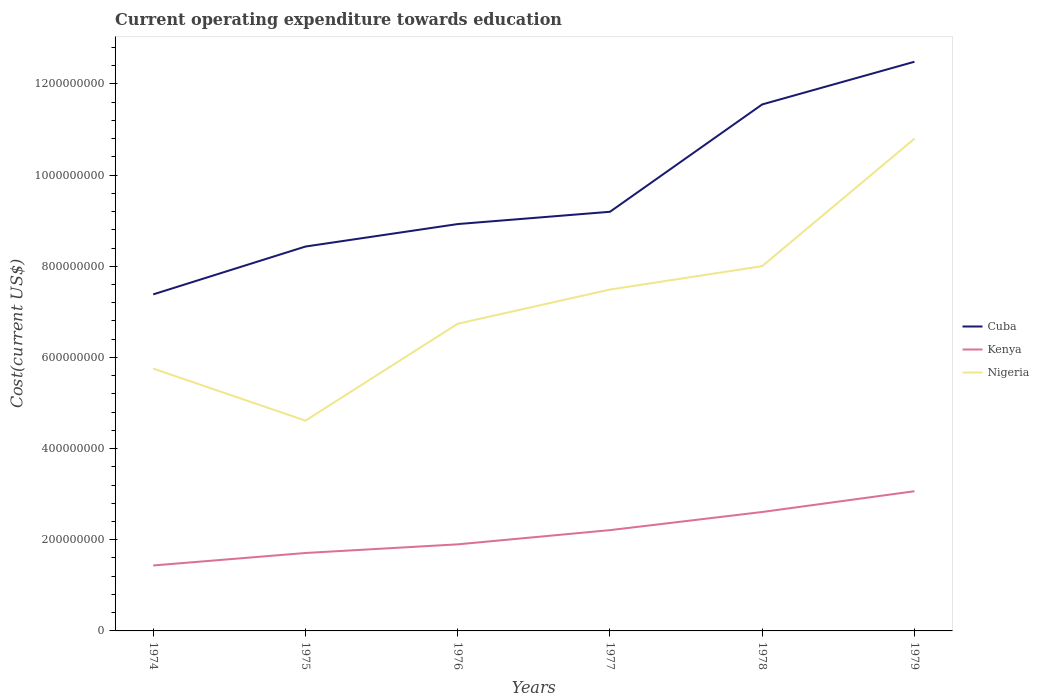How many different coloured lines are there?
Your answer should be compact. 3. Does the line corresponding to Nigeria intersect with the line corresponding to Cuba?
Provide a short and direct response. No. Is the number of lines equal to the number of legend labels?
Provide a short and direct response. Yes. Across all years, what is the maximum expenditure towards education in Cuba?
Keep it short and to the point. 7.38e+08. In which year was the expenditure towards education in Cuba maximum?
Your answer should be very brief. 1974. What is the total expenditure towards education in Kenya in the graph?
Your response must be concise. -4.63e+07. What is the difference between the highest and the second highest expenditure towards education in Cuba?
Provide a short and direct response. 5.10e+08. What is the difference between the highest and the lowest expenditure towards education in Nigeria?
Offer a terse response. 3. Is the expenditure towards education in Cuba strictly greater than the expenditure towards education in Kenya over the years?
Offer a very short reply. No. How many years are there in the graph?
Offer a very short reply. 6. What is the difference between two consecutive major ticks on the Y-axis?
Your answer should be very brief. 2.00e+08. Where does the legend appear in the graph?
Offer a terse response. Center right. What is the title of the graph?
Give a very brief answer. Current operating expenditure towards education. Does "Mexico" appear as one of the legend labels in the graph?
Offer a very short reply. No. What is the label or title of the Y-axis?
Make the answer very short. Cost(current US$). What is the Cost(current US$) in Cuba in 1974?
Keep it short and to the point. 7.38e+08. What is the Cost(current US$) of Kenya in 1974?
Give a very brief answer. 1.44e+08. What is the Cost(current US$) in Nigeria in 1974?
Keep it short and to the point. 5.76e+08. What is the Cost(current US$) in Cuba in 1975?
Ensure brevity in your answer.  8.43e+08. What is the Cost(current US$) of Kenya in 1975?
Your answer should be compact. 1.71e+08. What is the Cost(current US$) of Nigeria in 1975?
Provide a short and direct response. 4.61e+08. What is the Cost(current US$) of Cuba in 1976?
Ensure brevity in your answer.  8.93e+08. What is the Cost(current US$) of Kenya in 1976?
Keep it short and to the point. 1.90e+08. What is the Cost(current US$) of Nigeria in 1976?
Make the answer very short. 6.74e+08. What is the Cost(current US$) in Cuba in 1977?
Offer a very short reply. 9.20e+08. What is the Cost(current US$) in Kenya in 1977?
Your answer should be compact. 2.21e+08. What is the Cost(current US$) of Nigeria in 1977?
Ensure brevity in your answer.  7.49e+08. What is the Cost(current US$) in Cuba in 1978?
Your answer should be very brief. 1.16e+09. What is the Cost(current US$) of Kenya in 1978?
Your answer should be compact. 2.61e+08. What is the Cost(current US$) of Nigeria in 1978?
Make the answer very short. 8.00e+08. What is the Cost(current US$) of Cuba in 1979?
Give a very brief answer. 1.25e+09. What is the Cost(current US$) in Kenya in 1979?
Provide a short and direct response. 3.07e+08. What is the Cost(current US$) in Nigeria in 1979?
Ensure brevity in your answer.  1.08e+09. Across all years, what is the maximum Cost(current US$) of Cuba?
Make the answer very short. 1.25e+09. Across all years, what is the maximum Cost(current US$) in Kenya?
Your response must be concise. 3.07e+08. Across all years, what is the maximum Cost(current US$) of Nigeria?
Offer a very short reply. 1.08e+09. Across all years, what is the minimum Cost(current US$) in Cuba?
Offer a very short reply. 7.38e+08. Across all years, what is the minimum Cost(current US$) of Kenya?
Ensure brevity in your answer.  1.44e+08. Across all years, what is the minimum Cost(current US$) in Nigeria?
Give a very brief answer. 4.61e+08. What is the total Cost(current US$) of Cuba in the graph?
Offer a very short reply. 5.80e+09. What is the total Cost(current US$) of Kenya in the graph?
Make the answer very short. 1.29e+09. What is the total Cost(current US$) in Nigeria in the graph?
Keep it short and to the point. 4.34e+09. What is the difference between the Cost(current US$) in Cuba in 1974 and that in 1975?
Offer a very short reply. -1.05e+08. What is the difference between the Cost(current US$) of Kenya in 1974 and that in 1975?
Provide a succinct answer. -2.74e+07. What is the difference between the Cost(current US$) of Nigeria in 1974 and that in 1975?
Give a very brief answer. 1.14e+08. What is the difference between the Cost(current US$) of Cuba in 1974 and that in 1976?
Provide a short and direct response. -1.54e+08. What is the difference between the Cost(current US$) in Kenya in 1974 and that in 1976?
Make the answer very short. -4.63e+07. What is the difference between the Cost(current US$) of Nigeria in 1974 and that in 1976?
Your answer should be compact. -9.84e+07. What is the difference between the Cost(current US$) in Cuba in 1974 and that in 1977?
Give a very brief answer. -1.81e+08. What is the difference between the Cost(current US$) of Kenya in 1974 and that in 1977?
Keep it short and to the point. -7.75e+07. What is the difference between the Cost(current US$) of Nigeria in 1974 and that in 1977?
Ensure brevity in your answer.  -1.73e+08. What is the difference between the Cost(current US$) in Cuba in 1974 and that in 1978?
Provide a succinct answer. -4.17e+08. What is the difference between the Cost(current US$) in Kenya in 1974 and that in 1978?
Your response must be concise. -1.17e+08. What is the difference between the Cost(current US$) in Nigeria in 1974 and that in 1978?
Your response must be concise. -2.25e+08. What is the difference between the Cost(current US$) of Cuba in 1974 and that in 1979?
Your answer should be very brief. -5.10e+08. What is the difference between the Cost(current US$) in Kenya in 1974 and that in 1979?
Keep it short and to the point. -1.63e+08. What is the difference between the Cost(current US$) in Nigeria in 1974 and that in 1979?
Offer a very short reply. -5.04e+08. What is the difference between the Cost(current US$) of Cuba in 1975 and that in 1976?
Offer a very short reply. -4.93e+07. What is the difference between the Cost(current US$) in Kenya in 1975 and that in 1976?
Your answer should be very brief. -1.90e+07. What is the difference between the Cost(current US$) of Nigeria in 1975 and that in 1976?
Offer a very short reply. -2.13e+08. What is the difference between the Cost(current US$) of Cuba in 1975 and that in 1977?
Give a very brief answer. -7.63e+07. What is the difference between the Cost(current US$) in Kenya in 1975 and that in 1977?
Offer a very short reply. -5.02e+07. What is the difference between the Cost(current US$) of Nigeria in 1975 and that in 1977?
Give a very brief answer. -2.88e+08. What is the difference between the Cost(current US$) of Cuba in 1975 and that in 1978?
Offer a terse response. -3.12e+08. What is the difference between the Cost(current US$) in Kenya in 1975 and that in 1978?
Offer a very short reply. -8.99e+07. What is the difference between the Cost(current US$) in Nigeria in 1975 and that in 1978?
Provide a succinct answer. -3.39e+08. What is the difference between the Cost(current US$) in Cuba in 1975 and that in 1979?
Give a very brief answer. -4.05e+08. What is the difference between the Cost(current US$) of Kenya in 1975 and that in 1979?
Offer a very short reply. -1.36e+08. What is the difference between the Cost(current US$) of Nigeria in 1975 and that in 1979?
Make the answer very short. -6.19e+08. What is the difference between the Cost(current US$) of Cuba in 1976 and that in 1977?
Keep it short and to the point. -2.69e+07. What is the difference between the Cost(current US$) of Kenya in 1976 and that in 1977?
Provide a succinct answer. -3.12e+07. What is the difference between the Cost(current US$) of Nigeria in 1976 and that in 1977?
Make the answer very short. -7.50e+07. What is the difference between the Cost(current US$) in Cuba in 1976 and that in 1978?
Your answer should be very brief. -2.63e+08. What is the difference between the Cost(current US$) in Kenya in 1976 and that in 1978?
Provide a succinct answer. -7.10e+07. What is the difference between the Cost(current US$) in Nigeria in 1976 and that in 1978?
Ensure brevity in your answer.  -1.26e+08. What is the difference between the Cost(current US$) in Cuba in 1976 and that in 1979?
Keep it short and to the point. -3.56e+08. What is the difference between the Cost(current US$) in Kenya in 1976 and that in 1979?
Your response must be concise. -1.17e+08. What is the difference between the Cost(current US$) of Nigeria in 1976 and that in 1979?
Make the answer very short. -4.06e+08. What is the difference between the Cost(current US$) in Cuba in 1977 and that in 1978?
Your answer should be compact. -2.36e+08. What is the difference between the Cost(current US$) of Kenya in 1977 and that in 1978?
Provide a succinct answer. -3.98e+07. What is the difference between the Cost(current US$) of Nigeria in 1977 and that in 1978?
Your answer should be very brief. -5.14e+07. What is the difference between the Cost(current US$) in Cuba in 1977 and that in 1979?
Ensure brevity in your answer.  -3.29e+08. What is the difference between the Cost(current US$) in Kenya in 1977 and that in 1979?
Offer a very short reply. -8.54e+07. What is the difference between the Cost(current US$) of Nigeria in 1977 and that in 1979?
Your answer should be very brief. -3.31e+08. What is the difference between the Cost(current US$) in Cuba in 1978 and that in 1979?
Provide a short and direct response. -9.36e+07. What is the difference between the Cost(current US$) in Kenya in 1978 and that in 1979?
Your answer should be compact. -4.56e+07. What is the difference between the Cost(current US$) of Nigeria in 1978 and that in 1979?
Your answer should be compact. -2.80e+08. What is the difference between the Cost(current US$) of Cuba in 1974 and the Cost(current US$) of Kenya in 1975?
Make the answer very short. 5.67e+08. What is the difference between the Cost(current US$) of Cuba in 1974 and the Cost(current US$) of Nigeria in 1975?
Your answer should be compact. 2.77e+08. What is the difference between the Cost(current US$) of Kenya in 1974 and the Cost(current US$) of Nigeria in 1975?
Keep it short and to the point. -3.18e+08. What is the difference between the Cost(current US$) in Cuba in 1974 and the Cost(current US$) in Kenya in 1976?
Give a very brief answer. 5.48e+08. What is the difference between the Cost(current US$) in Cuba in 1974 and the Cost(current US$) in Nigeria in 1976?
Your answer should be very brief. 6.44e+07. What is the difference between the Cost(current US$) in Kenya in 1974 and the Cost(current US$) in Nigeria in 1976?
Your answer should be compact. -5.30e+08. What is the difference between the Cost(current US$) of Cuba in 1974 and the Cost(current US$) of Kenya in 1977?
Provide a succinct answer. 5.17e+08. What is the difference between the Cost(current US$) in Cuba in 1974 and the Cost(current US$) in Nigeria in 1977?
Your answer should be very brief. -1.06e+07. What is the difference between the Cost(current US$) in Kenya in 1974 and the Cost(current US$) in Nigeria in 1977?
Make the answer very short. -6.05e+08. What is the difference between the Cost(current US$) in Cuba in 1974 and the Cost(current US$) in Kenya in 1978?
Provide a succinct answer. 4.77e+08. What is the difference between the Cost(current US$) in Cuba in 1974 and the Cost(current US$) in Nigeria in 1978?
Your answer should be compact. -6.20e+07. What is the difference between the Cost(current US$) of Kenya in 1974 and the Cost(current US$) of Nigeria in 1978?
Ensure brevity in your answer.  -6.57e+08. What is the difference between the Cost(current US$) of Cuba in 1974 and the Cost(current US$) of Kenya in 1979?
Offer a very short reply. 4.32e+08. What is the difference between the Cost(current US$) of Cuba in 1974 and the Cost(current US$) of Nigeria in 1979?
Give a very brief answer. -3.42e+08. What is the difference between the Cost(current US$) in Kenya in 1974 and the Cost(current US$) in Nigeria in 1979?
Your response must be concise. -9.36e+08. What is the difference between the Cost(current US$) in Cuba in 1975 and the Cost(current US$) in Kenya in 1976?
Your answer should be compact. 6.53e+08. What is the difference between the Cost(current US$) of Cuba in 1975 and the Cost(current US$) of Nigeria in 1976?
Provide a succinct answer. 1.69e+08. What is the difference between the Cost(current US$) of Kenya in 1975 and the Cost(current US$) of Nigeria in 1976?
Ensure brevity in your answer.  -5.03e+08. What is the difference between the Cost(current US$) of Cuba in 1975 and the Cost(current US$) of Kenya in 1977?
Provide a short and direct response. 6.22e+08. What is the difference between the Cost(current US$) of Cuba in 1975 and the Cost(current US$) of Nigeria in 1977?
Give a very brief answer. 9.44e+07. What is the difference between the Cost(current US$) in Kenya in 1975 and the Cost(current US$) in Nigeria in 1977?
Keep it short and to the point. -5.78e+08. What is the difference between the Cost(current US$) in Cuba in 1975 and the Cost(current US$) in Kenya in 1978?
Provide a succinct answer. 5.82e+08. What is the difference between the Cost(current US$) of Cuba in 1975 and the Cost(current US$) of Nigeria in 1978?
Offer a terse response. 4.30e+07. What is the difference between the Cost(current US$) in Kenya in 1975 and the Cost(current US$) in Nigeria in 1978?
Your response must be concise. -6.29e+08. What is the difference between the Cost(current US$) in Cuba in 1975 and the Cost(current US$) in Kenya in 1979?
Your response must be concise. 5.37e+08. What is the difference between the Cost(current US$) in Cuba in 1975 and the Cost(current US$) in Nigeria in 1979?
Make the answer very short. -2.37e+08. What is the difference between the Cost(current US$) in Kenya in 1975 and the Cost(current US$) in Nigeria in 1979?
Provide a short and direct response. -9.09e+08. What is the difference between the Cost(current US$) of Cuba in 1976 and the Cost(current US$) of Kenya in 1977?
Offer a terse response. 6.72e+08. What is the difference between the Cost(current US$) of Cuba in 1976 and the Cost(current US$) of Nigeria in 1977?
Provide a succinct answer. 1.44e+08. What is the difference between the Cost(current US$) of Kenya in 1976 and the Cost(current US$) of Nigeria in 1977?
Give a very brief answer. -5.59e+08. What is the difference between the Cost(current US$) of Cuba in 1976 and the Cost(current US$) of Kenya in 1978?
Provide a succinct answer. 6.32e+08. What is the difference between the Cost(current US$) of Cuba in 1976 and the Cost(current US$) of Nigeria in 1978?
Give a very brief answer. 9.23e+07. What is the difference between the Cost(current US$) in Kenya in 1976 and the Cost(current US$) in Nigeria in 1978?
Offer a very short reply. -6.10e+08. What is the difference between the Cost(current US$) in Cuba in 1976 and the Cost(current US$) in Kenya in 1979?
Keep it short and to the point. 5.86e+08. What is the difference between the Cost(current US$) of Cuba in 1976 and the Cost(current US$) of Nigeria in 1979?
Offer a very short reply. -1.87e+08. What is the difference between the Cost(current US$) of Kenya in 1976 and the Cost(current US$) of Nigeria in 1979?
Your answer should be very brief. -8.90e+08. What is the difference between the Cost(current US$) of Cuba in 1977 and the Cost(current US$) of Kenya in 1978?
Make the answer very short. 6.59e+08. What is the difference between the Cost(current US$) in Cuba in 1977 and the Cost(current US$) in Nigeria in 1978?
Your answer should be very brief. 1.19e+08. What is the difference between the Cost(current US$) of Kenya in 1977 and the Cost(current US$) of Nigeria in 1978?
Your answer should be very brief. -5.79e+08. What is the difference between the Cost(current US$) of Cuba in 1977 and the Cost(current US$) of Kenya in 1979?
Keep it short and to the point. 6.13e+08. What is the difference between the Cost(current US$) in Cuba in 1977 and the Cost(current US$) in Nigeria in 1979?
Offer a terse response. -1.60e+08. What is the difference between the Cost(current US$) in Kenya in 1977 and the Cost(current US$) in Nigeria in 1979?
Offer a terse response. -8.59e+08. What is the difference between the Cost(current US$) in Cuba in 1978 and the Cost(current US$) in Kenya in 1979?
Offer a terse response. 8.49e+08. What is the difference between the Cost(current US$) of Cuba in 1978 and the Cost(current US$) of Nigeria in 1979?
Offer a terse response. 7.51e+07. What is the difference between the Cost(current US$) in Kenya in 1978 and the Cost(current US$) in Nigeria in 1979?
Keep it short and to the point. -8.19e+08. What is the average Cost(current US$) of Cuba per year?
Give a very brief answer. 9.66e+08. What is the average Cost(current US$) of Kenya per year?
Keep it short and to the point. 2.16e+08. What is the average Cost(current US$) of Nigeria per year?
Provide a short and direct response. 7.23e+08. In the year 1974, what is the difference between the Cost(current US$) of Cuba and Cost(current US$) of Kenya?
Give a very brief answer. 5.95e+08. In the year 1974, what is the difference between the Cost(current US$) in Cuba and Cost(current US$) in Nigeria?
Give a very brief answer. 1.63e+08. In the year 1974, what is the difference between the Cost(current US$) of Kenya and Cost(current US$) of Nigeria?
Offer a terse response. -4.32e+08. In the year 1975, what is the difference between the Cost(current US$) in Cuba and Cost(current US$) in Kenya?
Your answer should be compact. 6.72e+08. In the year 1975, what is the difference between the Cost(current US$) of Cuba and Cost(current US$) of Nigeria?
Your answer should be very brief. 3.82e+08. In the year 1975, what is the difference between the Cost(current US$) of Kenya and Cost(current US$) of Nigeria?
Give a very brief answer. -2.90e+08. In the year 1976, what is the difference between the Cost(current US$) in Cuba and Cost(current US$) in Kenya?
Provide a succinct answer. 7.03e+08. In the year 1976, what is the difference between the Cost(current US$) in Cuba and Cost(current US$) in Nigeria?
Offer a very short reply. 2.19e+08. In the year 1976, what is the difference between the Cost(current US$) of Kenya and Cost(current US$) of Nigeria?
Offer a very short reply. -4.84e+08. In the year 1977, what is the difference between the Cost(current US$) in Cuba and Cost(current US$) in Kenya?
Your response must be concise. 6.98e+08. In the year 1977, what is the difference between the Cost(current US$) of Cuba and Cost(current US$) of Nigeria?
Your response must be concise. 1.71e+08. In the year 1977, what is the difference between the Cost(current US$) of Kenya and Cost(current US$) of Nigeria?
Provide a short and direct response. -5.28e+08. In the year 1978, what is the difference between the Cost(current US$) of Cuba and Cost(current US$) of Kenya?
Your answer should be compact. 8.94e+08. In the year 1978, what is the difference between the Cost(current US$) of Cuba and Cost(current US$) of Nigeria?
Provide a short and direct response. 3.55e+08. In the year 1978, what is the difference between the Cost(current US$) of Kenya and Cost(current US$) of Nigeria?
Offer a terse response. -5.39e+08. In the year 1979, what is the difference between the Cost(current US$) of Cuba and Cost(current US$) of Kenya?
Provide a succinct answer. 9.42e+08. In the year 1979, what is the difference between the Cost(current US$) of Cuba and Cost(current US$) of Nigeria?
Keep it short and to the point. 1.69e+08. In the year 1979, what is the difference between the Cost(current US$) of Kenya and Cost(current US$) of Nigeria?
Provide a short and direct response. -7.74e+08. What is the ratio of the Cost(current US$) of Cuba in 1974 to that in 1975?
Your answer should be very brief. 0.88. What is the ratio of the Cost(current US$) of Kenya in 1974 to that in 1975?
Provide a short and direct response. 0.84. What is the ratio of the Cost(current US$) of Nigeria in 1974 to that in 1975?
Your answer should be compact. 1.25. What is the ratio of the Cost(current US$) of Cuba in 1974 to that in 1976?
Your answer should be compact. 0.83. What is the ratio of the Cost(current US$) of Kenya in 1974 to that in 1976?
Give a very brief answer. 0.76. What is the ratio of the Cost(current US$) in Nigeria in 1974 to that in 1976?
Offer a terse response. 0.85. What is the ratio of the Cost(current US$) in Cuba in 1974 to that in 1977?
Offer a terse response. 0.8. What is the ratio of the Cost(current US$) of Kenya in 1974 to that in 1977?
Give a very brief answer. 0.65. What is the ratio of the Cost(current US$) in Nigeria in 1974 to that in 1977?
Your answer should be very brief. 0.77. What is the ratio of the Cost(current US$) in Cuba in 1974 to that in 1978?
Give a very brief answer. 0.64. What is the ratio of the Cost(current US$) in Kenya in 1974 to that in 1978?
Provide a succinct answer. 0.55. What is the ratio of the Cost(current US$) of Nigeria in 1974 to that in 1978?
Your response must be concise. 0.72. What is the ratio of the Cost(current US$) in Cuba in 1974 to that in 1979?
Provide a short and direct response. 0.59. What is the ratio of the Cost(current US$) in Kenya in 1974 to that in 1979?
Make the answer very short. 0.47. What is the ratio of the Cost(current US$) of Nigeria in 1974 to that in 1979?
Give a very brief answer. 0.53. What is the ratio of the Cost(current US$) in Cuba in 1975 to that in 1976?
Offer a very short reply. 0.94. What is the ratio of the Cost(current US$) in Kenya in 1975 to that in 1976?
Provide a succinct answer. 0.9. What is the ratio of the Cost(current US$) in Nigeria in 1975 to that in 1976?
Your answer should be very brief. 0.68. What is the ratio of the Cost(current US$) of Cuba in 1975 to that in 1977?
Give a very brief answer. 0.92. What is the ratio of the Cost(current US$) of Kenya in 1975 to that in 1977?
Make the answer very short. 0.77. What is the ratio of the Cost(current US$) of Nigeria in 1975 to that in 1977?
Your answer should be compact. 0.62. What is the ratio of the Cost(current US$) in Cuba in 1975 to that in 1978?
Ensure brevity in your answer.  0.73. What is the ratio of the Cost(current US$) of Kenya in 1975 to that in 1978?
Provide a short and direct response. 0.66. What is the ratio of the Cost(current US$) in Nigeria in 1975 to that in 1978?
Keep it short and to the point. 0.58. What is the ratio of the Cost(current US$) of Cuba in 1975 to that in 1979?
Your answer should be compact. 0.68. What is the ratio of the Cost(current US$) in Kenya in 1975 to that in 1979?
Provide a short and direct response. 0.56. What is the ratio of the Cost(current US$) in Nigeria in 1975 to that in 1979?
Provide a succinct answer. 0.43. What is the ratio of the Cost(current US$) of Cuba in 1976 to that in 1977?
Your answer should be compact. 0.97. What is the ratio of the Cost(current US$) of Kenya in 1976 to that in 1977?
Provide a succinct answer. 0.86. What is the ratio of the Cost(current US$) of Nigeria in 1976 to that in 1977?
Ensure brevity in your answer.  0.9. What is the ratio of the Cost(current US$) of Cuba in 1976 to that in 1978?
Provide a succinct answer. 0.77. What is the ratio of the Cost(current US$) in Kenya in 1976 to that in 1978?
Your response must be concise. 0.73. What is the ratio of the Cost(current US$) of Nigeria in 1976 to that in 1978?
Your response must be concise. 0.84. What is the ratio of the Cost(current US$) of Cuba in 1976 to that in 1979?
Provide a short and direct response. 0.71. What is the ratio of the Cost(current US$) in Kenya in 1976 to that in 1979?
Ensure brevity in your answer.  0.62. What is the ratio of the Cost(current US$) in Nigeria in 1976 to that in 1979?
Offer a very short reply. 0.62. What is the ratio of the Cost(current US$) in Cuba in 1977 to that in 1978?
Your response must be concise. 0.8. What is the ratio of the Cost(current US$) of Kenya in 1977 to that in 1978?
Make the answer very short. 0.85. What is the ratio of the Cost(current US$) in Nigeria in 1977 to that in 1978?
Keep it short and to the point. 0.94. What is the ratio of the Cost(current US$) in Cuba in 1977 to that in 1979?
Your answer should be compact. 0.74. What is the ratio of the Cost(current US$) in Kenya in 1977 to that in 1979?
Your answer should be compact. 0.72. What is the ratio of the Cost(current US$) in Nigeria in 1977 to that in 1979?
Offer a very short reply. 0.69. What is the ratio of the Cost(current US$) of Cuba in 1978 to that in 1979?
Ensure brevity in your answer.  0.93. What is the ratio of the Cost(current US$) in Kenya in 1978 to that in 1979?
Your response must be concise. 0.85. What is the ratio of the Cost(current US$) of Nigeria in 1978 to that in 1979?
Your response must be concise. 0.74. What is the difference between the highest and the second highest Cost(current US$) in Cuba?
Offer a very short reply. 9.36e+07. What is the difference between the highest and the second highest Cost(current US$) in Kenya?
Offer a terse response. 4.56e+07. What is the difference between the highest and the second highest Cost(current US$) in Nigeria?
Offer a very short reply. 2.80e+08. What is the difference between the highest and the lowest Cost(current US$) of Cuba?
Offer a very short reply. 5.10e+08. What is the difference between the highest and the lowest Cost(current US$) of Kenya?
Your response must be concise. 1.63e+08. What is the difference between the highest and the lowest Cost(current US$) of Nigeria?
Your answer should be very brief. 6.19e+08. 